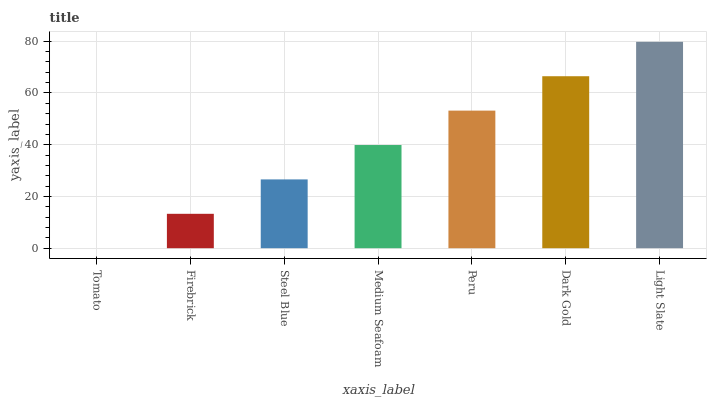Is Tomato the minimum?
Answer yes or no. Yes. Is Light Slate the maximum?
Answer yes or no. Yes. Is Firebrick the minimum?
Answer yes or no. No. Is Firebrick the maximum?
Answer yes or no. No. Is Firebrick greater than Tomato?
Answer yes or no. Yes. Is Tomato less than Firebrick?
Answer yes or no. Yes. Is Tomato greater than Firebrick?
Answer yes or no. No. Is Firebrick less than Tomato?
Answer yes or no. No. Is Medium Seafoam the high median?
Answer yes or no. Yes. Is Medium Seafoam the low median?
Answer yes or no. Yes. Is Tomato the high median?
Answer yes or no. No. Is Tomato the low median?
Answer yes or no. No. 